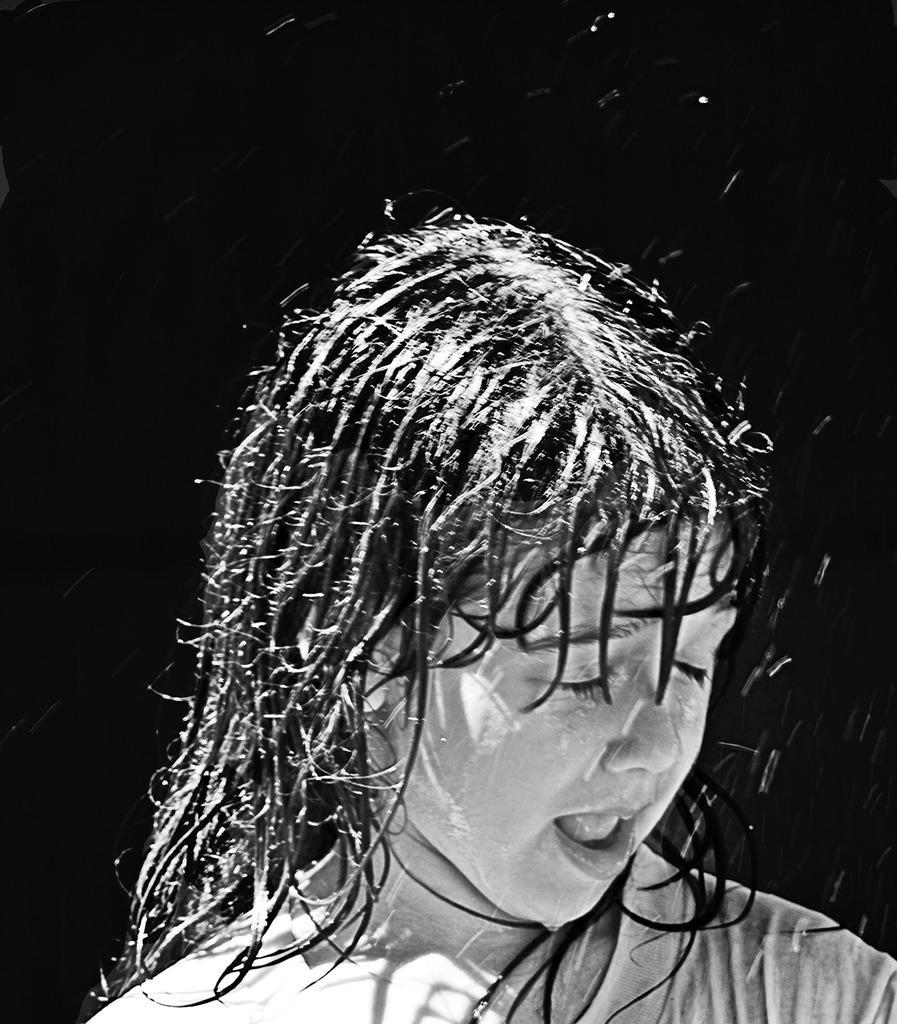Describe this image in one or two sentences. This is a black and white image. In this image, in the middle, we can see a kid who is taking a shower. In the background, we can see black color. 